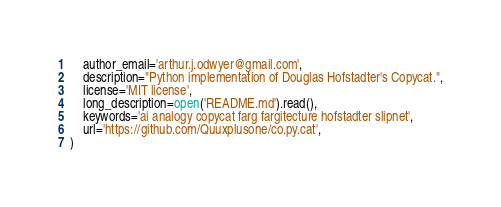Convert code to text. <code><loc_0><loc_0><loc_500><loc_500><_Python_>    author_email='arthur.j.odwyer@gmail.com',
    description="Python implementation of Douglas Hofstadter's Copycat.",
    license='MIT license',
    long_description=open('README.md').read(),
    keywords='ai analogy copycat farg fargitecture hofstadter slipnet',
    url='https://github.com/Quuxplusone/co.py.cat',
)
</code> 